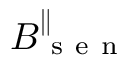Convert formula to latex. <formula><loc_0><loc_0><loc_500><loc_500>B _ { s e n } ^ { \| }</formula> 